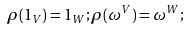<formula> <loc_0><loc_0><loc_500><loc_500>\rho ( 1 _ { V } ) = 1 _ { W } ; \rho ( \omega ^ { V } ) = \omega ^ { W } ;</formula> 